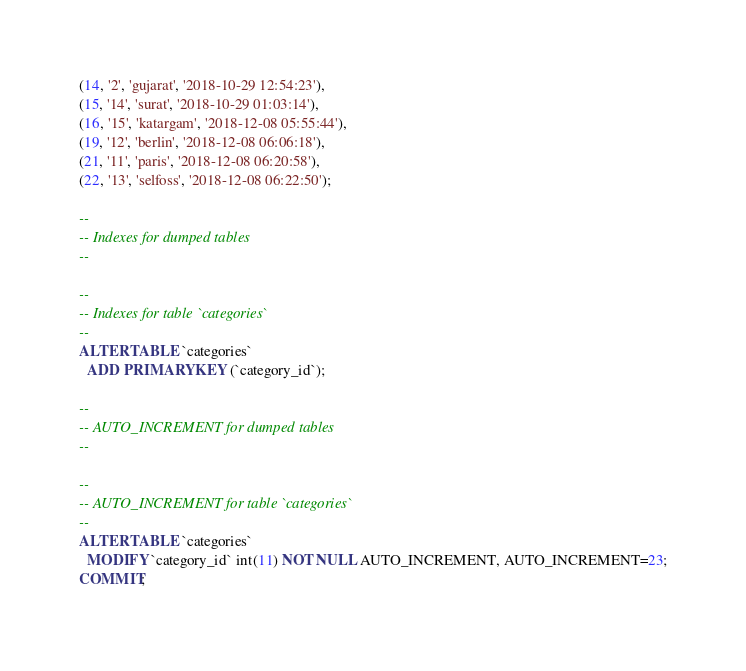<code> <loc_0><loc_0><loc_500><loc_500><_SQL_>(14, '2', 'gujarat', '2018-10-29 12:54:23'),
(15, '14', 'surat', '2018-10-29 01:03:14'),
(16, '15', 'katargam', '2018-12-08 05:55:44'),
(19, '12', 'berlin', '2018-12-08 06:06:18'),
(21, '11', 'paris', '2018-12-08 06:20:58'),
(22, '13', 'selfoss', '2018-12-08 06:22:50');

--
-- Indexes for dumped tables
--

--
-- Indexes for table `categories`
--
ALTER TABLE `categories`
  ADD PRIMARY KEY (`category_id`);

--
-- AUTO_INCREMENT for dumped tables
--

--
-- AUTO_INCREMENT for table `categories`
--
ALTER TABLE `categories`
  MODIFY `category_id` int(11) NOT NULL AUTO_INCREMENT, AUTO_INCREMENT=23;
COMMIT;</code> 